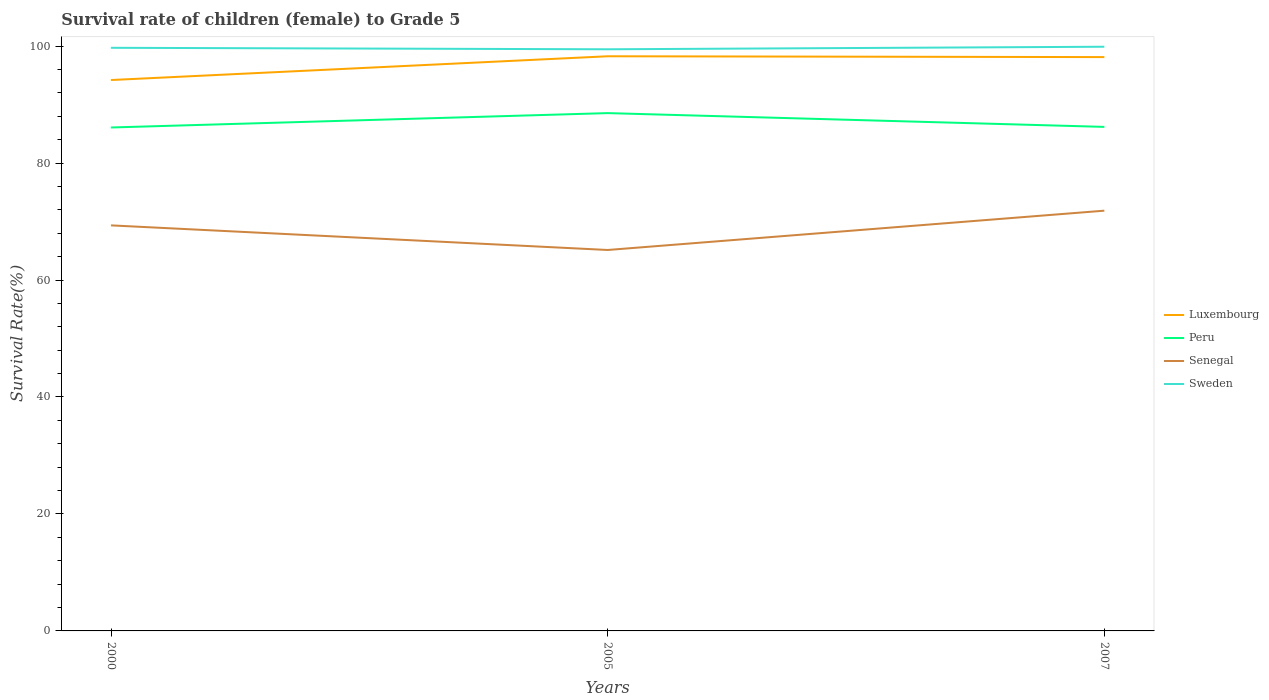How many different coloured lines are there?
Ensure brevity in your answer.  4. Does the line corresponding to Senegal intersect with the line corresponding to Sweden?
Give a very brief answer. No. Is the number of lines equal to the number of legend labels?
Offer a very short reply. Yes. Across all years, what is the maximum survival rate of female children to grade 5 in Sweden?
Your response must be concise. 99.45. What is the total survival rate of female children to grade 5 in Senegal in the graph?
Provide a short and direct response. -2.51. What is the difference between the highest and the second highest survival rate of female children to grade 5 in Sweden?
Your answer should be very brief. 0.43. How many years are there in the graph?
Your answer should be compact. 3. Where does the legend appear in the graph?
Your answer should be compact. Center right. What is the title of the graph?
Provide a short and direct response. Survival rate of children (female) to Grade 5. Does "Cuba" appear as one of the legend labels in the graph?
Your response must be concise. No. What is the label or title of the X-axis?
Provide a short and direct response. Years. What is the label or title of the Y-axis?
Make the answer very short. Survival Rate(%). What is the Survival Rate(%) of Luxembourg in 2000?
Provide a short and direct response. 94.2. What is the Survival Rate(%) of Peru in 2000?
Offer a very short reply. 86.08. What is the Survival Rate(%) in Senegal in 2000?
Your response must be concise. 69.34. What is the Survival Rate(%) of Sweden in 2000?
Offer a very short reply. 99.7. What is the Survival Rate(%) of Luxembourg in 2005?
Provide a succinct answer. 98.26. What is the Survival Rate(%) of Peru in 2005?
Your response must be concise. 88.54. What is the Survival Rate(%) in Senegal in 2005?
Keep it short and to the point. 65.13. What is the Survival Rate(%) of Sweden in 2005?
Ensure brevity in your answer.  99.45. What is the Survival Rate(%) in Luxembourg in 2007?
Keep it short and to the point. 98.12. What is the Survival Rate(%) in Peru in 2007?
Offer a terse response. 86.18. What is the Survival Rate(%) of Senegal in 2007?
Give a very brief answer. 71.86. What is the Survival Rate(%) of Sweden in 2007?
Provide a succinct answer. 99.89. Across all years, what is the maximum Survival Rate(%) of Luxembourg?
Your answer should be compact. 98.26. Across all years, what is the maximum Survival Rate(%) in Peru?
Your answer should be compact. 88.54. Across all years, what is the maximum Survival Rate(%) of Senegal?
Keep it short and to the point. 71.86. Across all years, what is the maximum Survival Rate(%) of Sweden?
Your response must be concise. 99.89. Across all years, what is the minimum Survival Rate(%) in Luxembourg?
Keep it short and to the point. 94.2. Across all years, what is the minimum Survival Rate(%) of Peru?
Make the answer very short. 86.08. Across all years, what is the minimum Survival Rate(%) of Senegal?
Keep it short and to the point. 65.13. Across all years, what is the minimum Survival Rate(%) in Sweden?
Ensure brevity in your answer.  99.45. What is the total Survival Rate(%) of Luxembourg in the graph?
Your response must be concise. 290.57. What is the total Survival Rate(%) of Peru in the graph?
Your response must be concise. 260.8. What is the total Survival Rate(%) in Senegal in the graph?
Provide a succinct answer. 206.33. What is the total Survival Rate(%) of Sweden in the graph?
Your response must be concise. 299.04. What is the difference between the Survival Rate(%) of Luxembourg in 2000 and that in 2005?
Provide a succinct answer. -4.06. What is the difference between the Survival Rate(%) of Peru in 2000 and that in 2005?
Give a very brief answer. -2.46. What is the difference between the Survival Rate(%) in Senegal in 2000 and that in 2005?
Your response must be concise. 4.21. What is the difference between the Survival Rate(%) of Sweden in 2000 and that in 2005?
Your answer should be compact. 0.25. What is the difference between the Survival Rate(%) in Luxembourg in 2000 and that in 2007?
Ensure brevity in your answer.  -3.92. What is the difference between the Survival Rate(%) in Peru in 2000 and that in 2007?
Offer a very short reply. -0.1. What is the difference between the Survival Rate(%) of Senegal in 2000 and that in 2007?
Your answer should be compact. -2.51. What is the difference between the Survival Rate(%) of Sweden in 2000 and that in 2007?
Ensure brevity in your answer.  -0.18. What is the difference between the Survival Rate(%) of Luxembourg in 2005 and that in 2007?
Ensure brevity in your answer.  0.14. What is the difference between the Survival Rate(%) of Peru in 2005 and that in 2007?
Keep it short and to the point. 2.36. What is the difference between the Survival Rate(%) in Senegal in 2005 and that in 2007?
Offer a very short reply. -6.72. What is the difference between the Survival Rate(%) of Sweden in 2005 and that in 2007?
Your answer should be compact. -0.43. What is the difference between the Survival Rate(%) in Luxembourg in 2000 and the Survival Rate(%) in Peru in 2005?
Offer a terse response. 5.66. What is the difference between the Survival Rate(%) of Luxembourg in 2000 and the Survival Rate(%) of Senegal in 2005?
Keep it short and to the point. 29.06. What is the difference between the Survival Rate(%) in Luxembourg in 2000 and the Survival Rate(%) in Sweden in 2005?
Offer a terse response. -5.26. What is the difference between the Survival Rate(%) of Peru in 2000 and the Survival Rate(%) of Senegal in 2005?
Provide a short and direct response. 20.95. What is the difference between the Survival Rate(%) in Peru in 2000 and the Survival Rate(%) in Sweden in 2005?
Provide a short and direct response. -13.37. What is the difference between the Survival Rate(%) in Senegal in 2000 and the Survival Rate(%) in Sweden in 2005?
Offer a terse response. -30.11. What is the difference between the Survival Rate(%) of Luxembourg in 2000 and the Survival Rate(%) of Peru in 2007?
Your answer should be very brief. 8.01. What is the difference between the Survival Rate(%) in Luxembourg in 2000 and the Survival Rate(%) in Senegal in 2007?
Ensure brevity in your answer.  22.34. What is the difference between the Survival Rate(%) in Luxembourg in 2000 and the Survival Rate(%) in Sweden in 2007?
Make the answer very short. -5.69. What is the difference between the Survival Rate(%) of Peru in 2000 and the Survival Rate(%) of Senegal in 2007?
Provide a succinct answer. 14.22. What is the difference between the Survival Rate(%) of Peru in 2000 and the Survival Rate(%) of Sweden in 2007?
Keep it short and to the point. -13.81. What is the difference between the Survival Rate(%) of Senegal in 2000 and the Survival Rate(%) of Sweden in 2007?
Give a very brief answer. -30.54. What is the difference between the Survival Rate(%) of Luxembourg in 2005 and the Survival Rate(%) of Peru in 2007?
Give a very brief answer. 12.07. What is the difference between the Survival Rate(%) in Luxembourg in 2005 and the Survival Rate(%) in Senegal in 2007?
Offer a terse response. 26.4. What is the difference between the Survival Rate(%) of Luxembourg in 2005 and the Survival Rate(%) of Sweden in 2007?
Provide a short and direct response. -1.63. What is the difference between the Survival Rate(%) of Peru in 2005 and the Survival Rate(%) of Senegal in 2007?
Make the answer very short. 16.68. What is the difference between the Survival Rate(%) of Peru in 2005 and the Survival Rate(%) of Sweden in 2007?
Provide a short and direct response. -11.35. What is the difference between the Survival Rate(%) of Senegal in 2005 and the Survival Rate(%) of Sweden in 2007?
Offer a very short reply. -34.75. What is the average Survival Rate(%) in Luxembourg per year?
Ensure brevity in your answer.  96.86. What is the average Survival Rate(%) in Peru per year?
Give a very brief answer. 86.93. What is the average Survival Rate(%) of Senegal per year?
Your answer should be very brief. 68.78. What is the average Survival Rate(%) of Sweden per year?
Your answer should be compact. 99.68. In the year 2000, what is the difference between the Survival Rate(%) in Luxembourg and Survival Rate(%) in Peru?
Your answer should be very brief. 8.12. In the year 2000, what is the difference between the Survival Rate(%) in Luxembourg and Survival Rate(%) in Senegal?
Ensure brevity in your answer.  24.85. In the year 2000, what is the difference between the Survival Rate(%) of Luxembourg and Survival Rate(%) of Sweden?
Give a very brief answer. -5.51. In the year 2000, what is the difference between the Survival Rate(%) in Peru and Survival Rate(%) in Senegal?
Provide a short and direct response. 16.74. In the year 2000, what is the difference between the Survival Rate(%) of Peru and Survival Rate(%) of Sweden?
Provide a short and direct response. -13.63. In the year 2000, what is the difference between the Survival Rate(%) of Senegal and Survival Rate(%) of Sweden?
Keep it short and to the point. -30.36. In the year 2005, what is the difference between the Survival Rate(%) of Luxembourg and Survival Rate(%) of Peru?
Provide a short and direct response. 9.72. In the year 2005, what is the difference between the Survival Rate(%) of Luxembourg and Survival Rate(%) of Senegal?
Give a very brief answer. 33.12. In the year 2005, what is the difference between the Survival Rate(%) in Luxembourg and Survival Rate(%) in Sweden?
Provide a succinct answer. -1.2. In the year 2005, what is the difference between the Survival Rate(%) of Peru and Survival Rate(%) of Senegal?
Provide a short and direct response. 23.4. In the year 2005, what is the difference between the Survival Rate(%) in Peru and Survival Rate(%) in Sweden?
Offer a terse response. -10.91. In the year 2005, what is the difference between the Survival Rate(%) in Senegal and Survival Rate(%) in Sweden?
Keep it short and to the point. -34.32. In the year 2007, what is the difference between the Survival Rate(%) of Luxembourg and Survival Rate(%) of Peru?
Offer a terse response. 11.93. In the year 2007, what is the difference between the Survival Rate(%) in Luxembourg and Survival Rate(%) in Senegal?
Make the answer very short. 26.26. In the year 2007, what is the difference between the Survival Rate(%) of Luxembourg and Survival Rate(%) of Sweden?
Your response must be concise. -1.77. In the year 2007, what is the difference between the Survival Rate(%) of Peru and Survival Rate(%) of Senegal?
Your response must be concise. 14.33. In the year 2007, what is the difference between the Survival Rate(%) of Peru and Survival Rate(%) of Sweden?
Your answer should be very brief. -13.7. In the year 2007, what is the difference between the Survival Rate(%) in Senegal and Survival Rate(%) in Sweden?
Offer a very short reply. -28.03. What is the ratio of the Survival Rate(%) in Luxembourg in 2000 to that in 2005?
Ensure brevity in your answer.  0.96. What is the ratio of the Survival Rate(%) in Peru in 2000 to that in 2005?
Offer a terse response. 0.97. What is the ratio of the Survival Rate(%) in Senegal in 2000 to that in 2005?
Your response must be concise. 1.06. What is the ratio of the Survival Rate(%) of Sweden in 2000 to that in 2005?
Ensure brevity in your answer.  1. What is the ratio of the Survival Rate(%) in Luxembourg in 2000 to that in 2007?
Ensure brevity in your answer.  0.96. What is the ratio of the Survival Rate(%) in Peru in 2000 to that in 2007?
Your response must be concise. 1. What is the ratio of the Survival Rate(%) in Peru in 2005 to that in 2007?
Provide a short and direct response. 1.03. What is the ratio of the Survival Rate(%) in Senegal in 2005 to that in 2007?
Give a very brief answer. 0.91. What is the difference between the highest and the second highest Survival Rate(%) of Luxembourg?
Offer a terse response. 0.14. What is the difference between the highest and the second highest Survival Rate(%) of Peru?
Offer a terse response. 2.36. What is the difference between the highest and the second highest Survival Rate(%) in Senegal?
Your answer should be compact. 2.51. What is the difference between the highest and the second highest Survival Rate(%) in Sweden?
Give a very brief answer. 0.18. What is the difference between the highest and the lowest Survival Rate(%) of Luxembourg?
Your response must be concise. 4.06. What is the difference between the highest and the lowest Survival Rate(%) of Peru?
Keep it short and to the point. 2.46. What is the difference between the highest and the lowest Survival Rate(%) in Senegal?
Provide a succinct answer. 6.72. What is the difference between the highest and the lowest Survival Rate(%) in Sweden?
Provide a short and direct response. 0.43. 